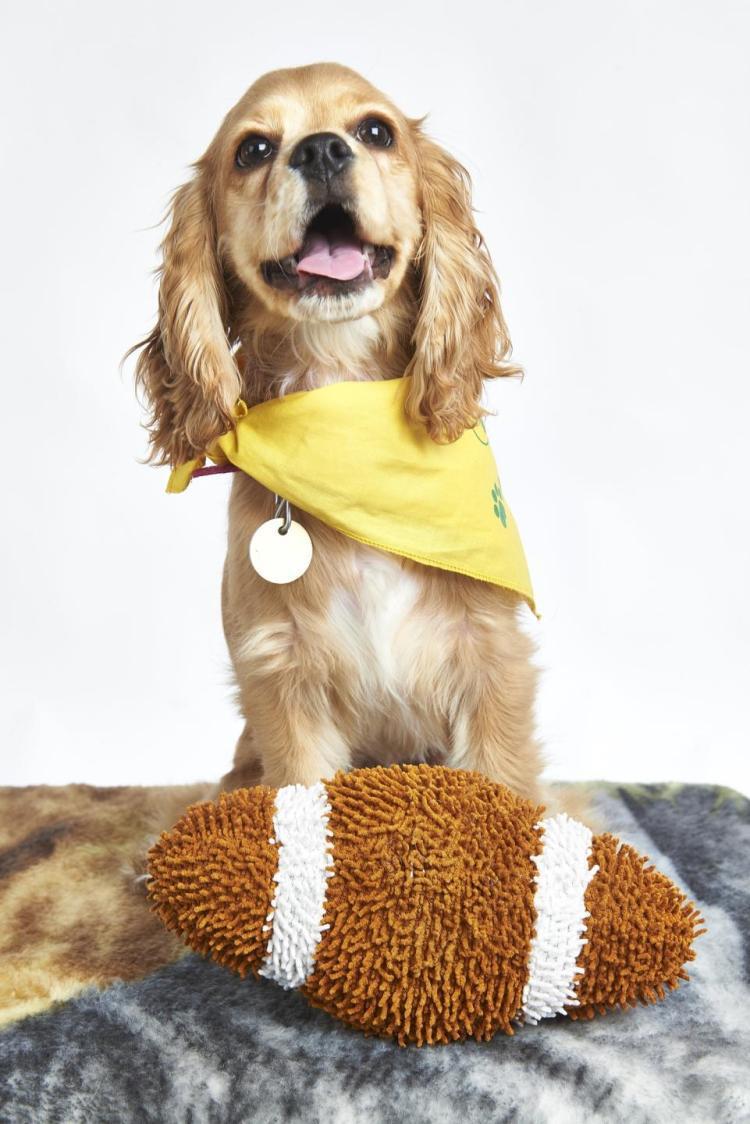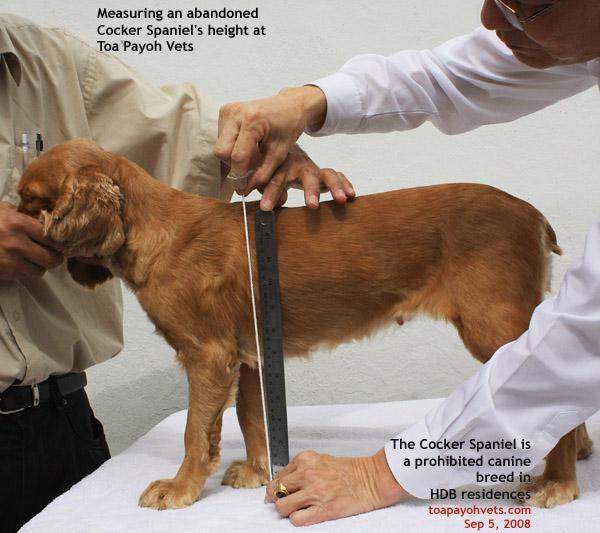The first image is the image on the left, the second image is the image on the right. Examine the images to the left and right. Is the description "An image includes an orange cocker spaniel with its nose in a dog bowl without a patterned design." accurate? Answer yes or no. No. The first image is the image on the left, the second image is the image on the right. Analyze the images presented: Is the assertion "The dog in the image on the left is eating out of a bowl." valid? Answer yes or no. No. 